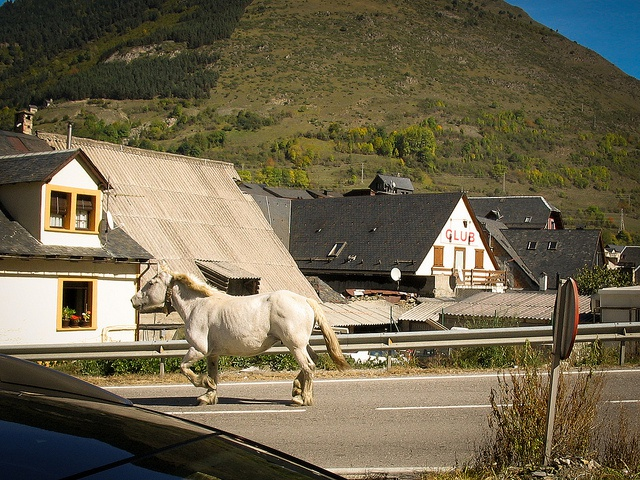Describe the objects in this image and their specific colors. I can see car in teal, black, and gray tones, horse in teal, beige, tan, olive, and gray tones, potted plant in teal, black, olive, maroon, and brown tones, and potted plant in teal, black, maroon, and olive tones in this image. 